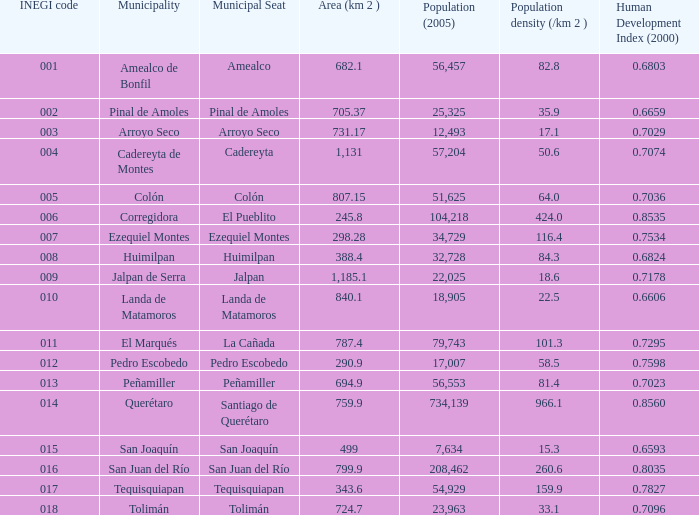Which inegi code possesses a population density (/km 2 ) less than 8 15.0. Could you parse the entire table? {'header': ['INEGI code', 'Municipality', 'Municipal Seat', 'Area (km 2 )', 'Population (2005)', 'Population density (/km 2 )', 'Human Development Index (2000)'], 'rows': [['001', 'Amealco de Bonfil', 'Amealco', '682.1', '56,457', '82.8', '0.6803'], ['002', 'Pinal de Amoles', 'Pinal de Amoles', '705.37', '25,325', '35.9', '0.6659'], ['003', 'Arroyo Seco', 'Arroyo Seco', '731.17', '12,493', '17.1', '0.7029'], ['004', 'Cadereyta de Montes', 'Cadereyta', '1,131', '57,204', '50.6', '0.7074'], ['005', 'Colón', 'Colón', '807.15', '51,625', '64.0', '0.7036'], ['006', 'Corregidora', 'El Pueblito', '245.8', '104,218', '424.0', '0.8535'], ['007', 'Ezequiel Montes', 'Ezequiel Montes', '298.28', '34,729', '116.4', '0.7534'], ['008', 'Huimilpan', 'Huimilpan', '388.4', '32,728', '84.3', '0.6824'], ['009', 'Jalpan de Serra', 'Jalpan', '1,185.1', '22,025', '18.6', '0.7178'], ['010', 'Landa de Matamoros', 'Landa de Matamoros', '840.1', '18,905', '22.5', '0.6606'], ['011', 'El Marqués', 'La Cañada', '787.4', '79,743', '101.3', '0.7295'], ['012', 'Pedro Escobedo', 'Pedro Escobedo', '290.9', '17,007', '58.5', '0.7598'], ['013', 'Peñamiller', 'Peñamiller', '694.9', '56,553', '81.4', '0.7023'], ['014', 'Querétaro', 'Santiago de Querétaro', '759.9', '734,139', '966.1', '0.8560'], ['015', 'San Joaquín', 'San Joaquín', '499', '7,634', '15.3', '0.6593'], ['016', 'San Juan del Río', 'San Juan del Río', '799.9', '208,462', '260.6', '0.8035'], ['017', 'Tequisquiapan', 'Tequisquiapan', '343.6', '54,929', '159.9', '0.7827'], ['018', 'Tolimán', 'Tolimán', '724.7', '23,963', '33.1', '0.7096']]} 